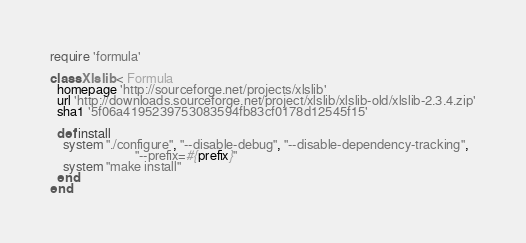<code> <loc_0><loc_0><loc_500><loc_500><_Ruby_>require 'formula'

class Xlslib < Formula
  homepage 'http://sourceforge.net/projects/xlslib'
  url 'http://downloads.sourceforge.net/project/xlslib/xlslib-old/xlslib-2.3.4.zip'
  sha1 '5f06a4195239753083594fb83cf0178d12545f15'

  def install
    system "./configure", "--disable-debug", "--disable-dependency-tracking",
                          "--prefix=#{prefix}"
    system "make install"
  end
end
</code> 